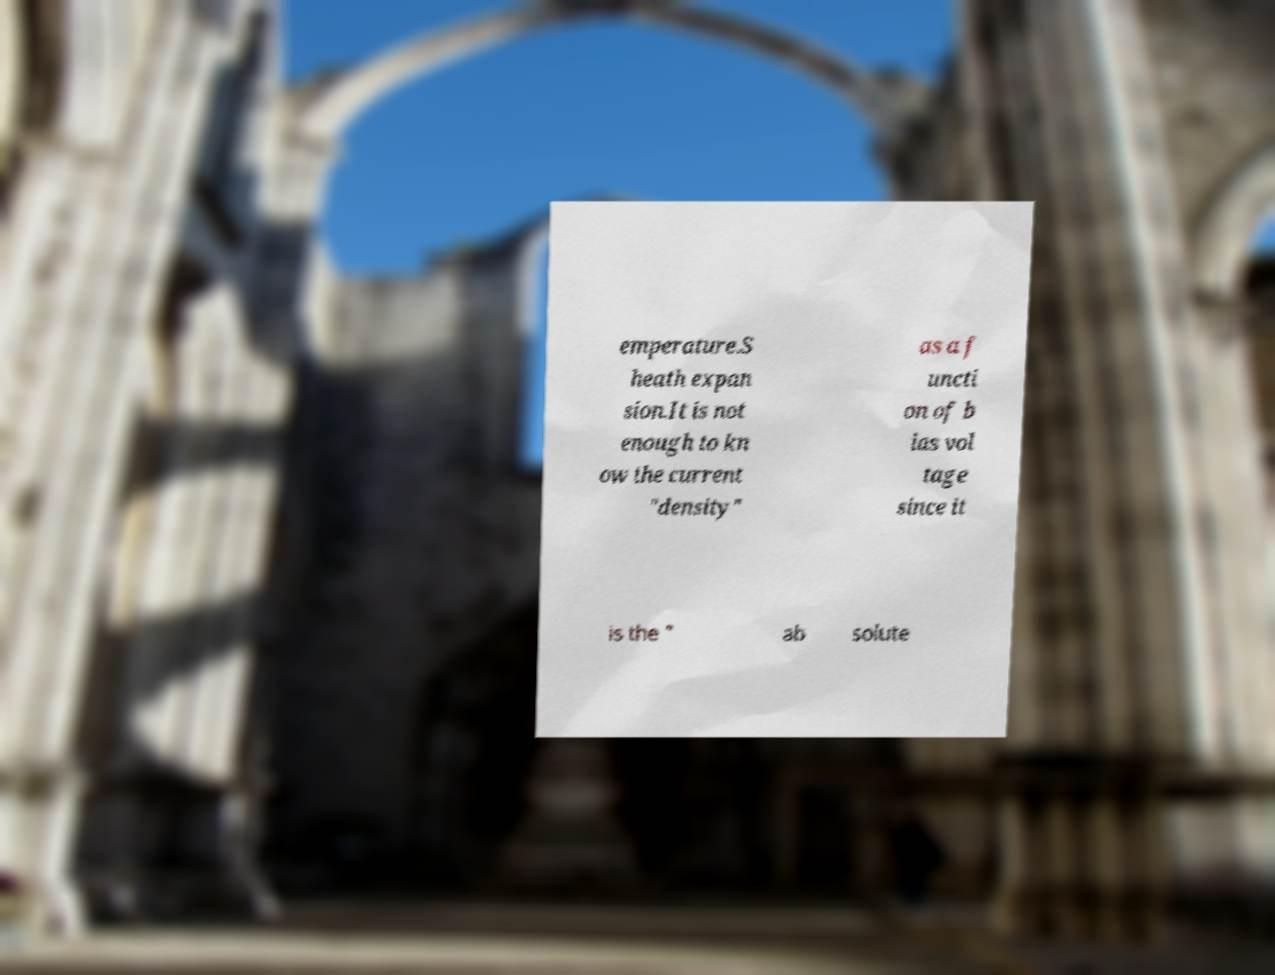Could you assist in decoding the text presented in this image and type it out clearly? emperature.S heath expan sion.It is not enough to kn ow the current "density" as a f uncti on of b ias vol tage since it is the " ab solute 